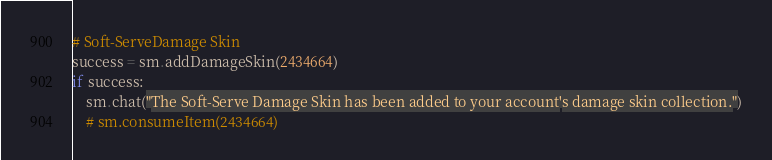<code> <loc_0><loc_0><loc_500><loc_500><_Python_># Soft-ServeDamage Skin
success = sm.addDamageSkin(2434664)
if success:
    sm.chat("The Soft-Serve Damage Skin has been added to your account's damage skin collection.")
    # sm.consumeItem(2434664)
</code> 